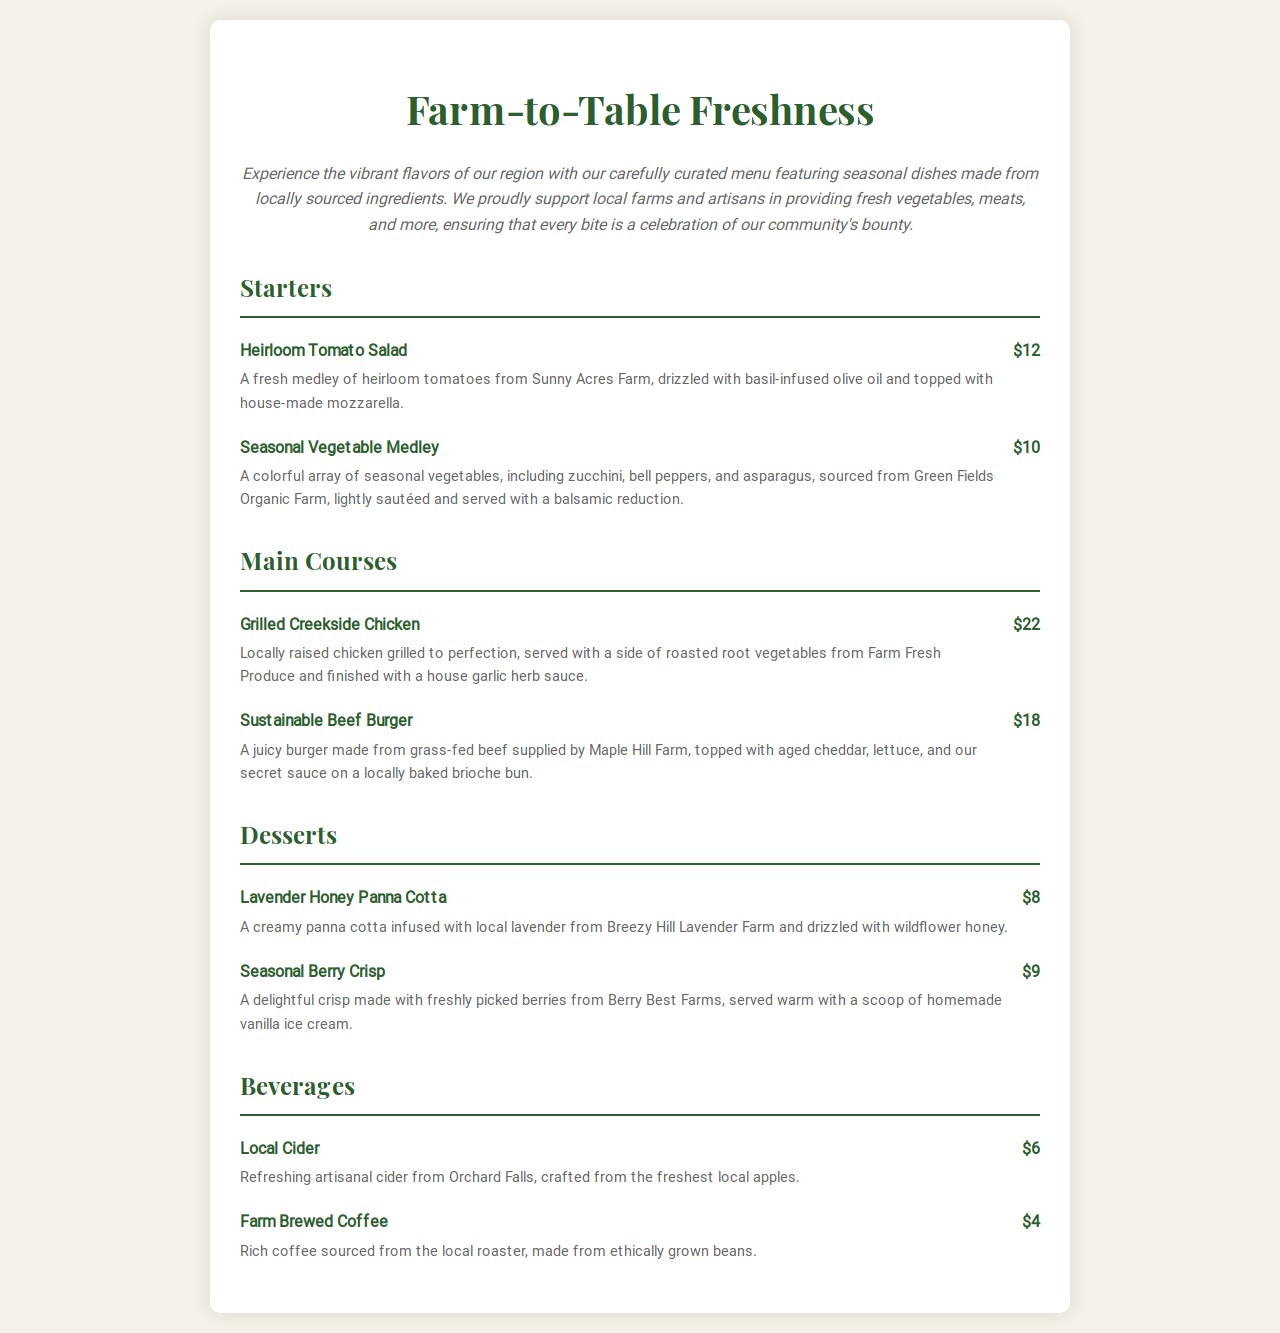What is the price of the Heirloom Tomato Salad? The price of the Heirloom Tomato Salad is listed in the menu under the Starters section.
Answer: $12 What type of chicken is served in the Grilled Creekside Chicken dish? The type of chicken is mentioned in the description of the Grilled Creekside Chicken menu item.
Answer: Locally raised chicken Which farm provides the beef for the Sustainable Beef Burger? The specific farm for the beef is included in the description of the Sustainable Beef Burger.
Answer: Maple Hill Farm How many items are listed under Starters? The number of items is determined by counting the starter menu items provided in the document.
Answer: 2 What is the main ingredient in the Lavender Honey Panna Cotta? The main ingredient is highlighted in the description section for the Lavender Honey Panna Cotta.
Answer: Local lavender What beverage is made from fresh local apples? The beverage's origin is detailed in the Local Cider menu item's description.
Answer: Local Cider What type of dessert features berries from Berry Best Farms? The dessert type is specified in the description of the Seasonal Berry Crisp.
Answer: Seasonal Berry Crisp Which item is priced at $6? The price is associated with the Local Cider under the Beverages section.
Answer: Local Cider 